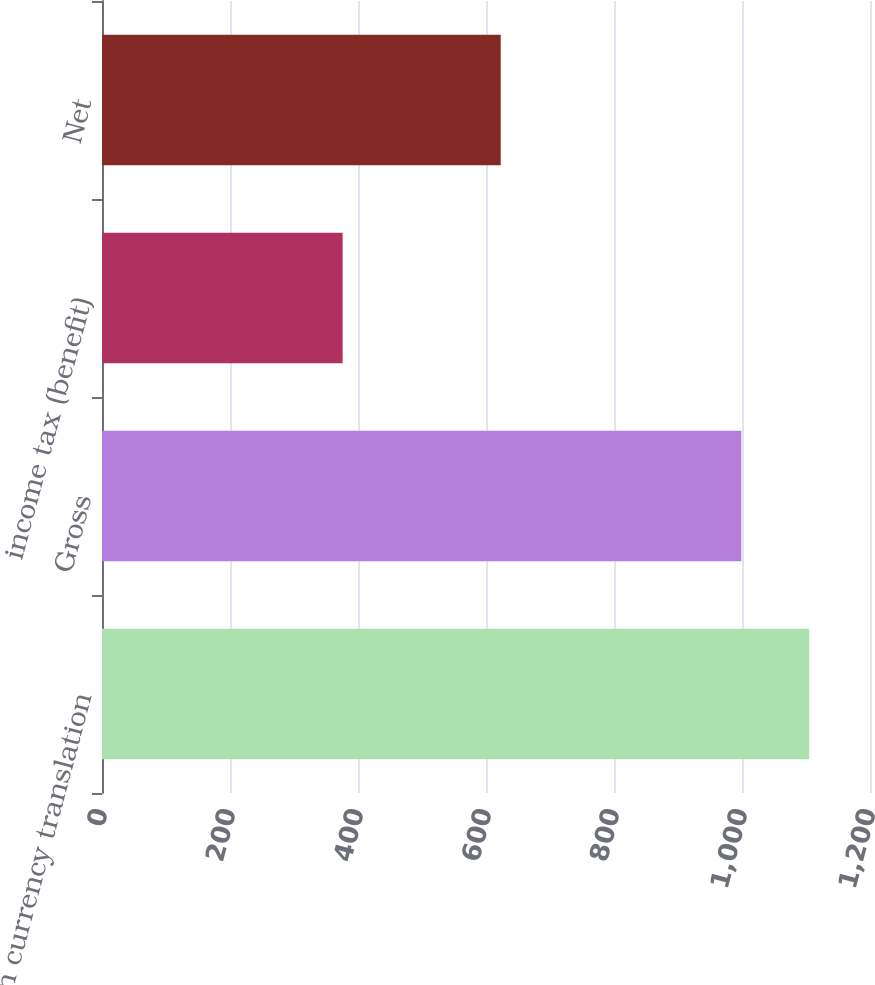Convert chart. <chart><loc_0><loc_0><loc_500><loc_500><bar_chart><fcel>foreign currency translation<fcel>Gross<fcel>income tax (benefit)<fcel>Net<nl><fcel>1105<fcel>999<fcel>376<fcel>623<nl></chart> 